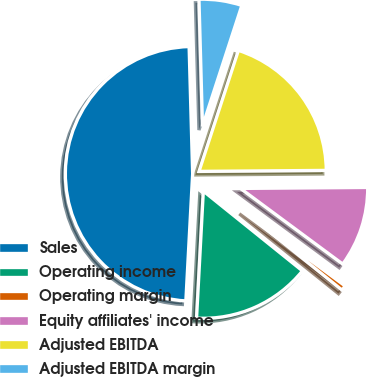<chart> <loc_0><loc_0><loc_500><loc_500><pie_chart><fcel>Sales<fcel>Operating income<fcel>Operating margin<fcel>Equity affiliates' income<fcel>Adjusted EBITDA<fcel>Adjusted EBITDA margin<nl><fcel>48.71%<fcel>15.06%<fcel>0.65%<fcel>10.26%<fcel>19.87%<fcel>5.45%<nl></chart> 